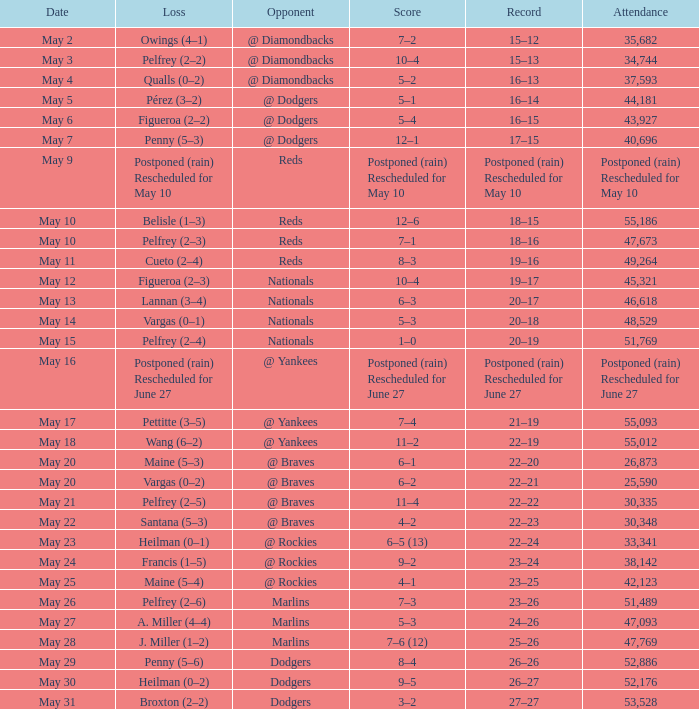Record of 22–20 involved what score? 6–1. 